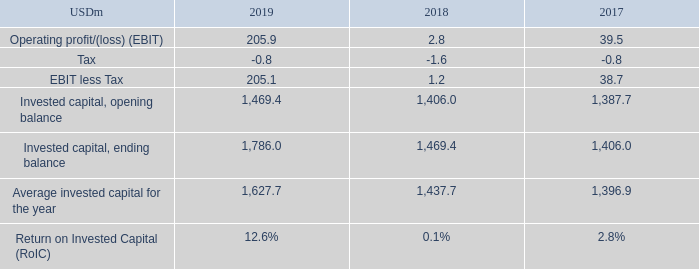ALTERNATIVE PERFORMANCE MEASURES – continued
Return on Invested Capital (RoIC): TORM defines RoIC as earnings before interest and tax (EBIT) less tax, divided by the average invested capital for the period. Invested capital is defined below.
RoIC expresses the returns generated on capital invested in the Group. The progression of RoIC is used by TORM to measure progress against our longer-term value creation goals outlined to investors. RoIC is calculated as follows:
How does TORM define RoIC? Torm defines roic as earnings before interest and tax (ebit) less tax, divided by the average invested capital for the period. What is the progression of RoIC used by TORM for? The progression of roic is used by torm to measure progress against our longer-term value creation goals outlined to investors. What are the components in the table which is used to directly derive the RoIC? Ebit less tax, average invested capital for the year. In which year was the Invested capital, opening balance the largest? 1,469.4>1,406.0>1,387.7
Answer: 2019. What was the change in the Average invested capital for the year in 2019 from 2018?
Answer scale should be: million. 1,627.7-1,437.7
Answer: 190. What was the percentage change in the Average invested capital for the year in 2019 from 2018?
Answer scale should be: percent. (1,627.7-1,437.7)/1,437.7
Answer: 13.22. 